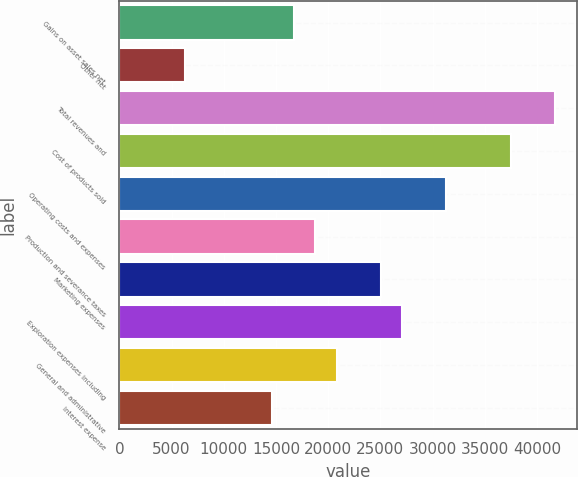<chart> <loc_0><loc_0><loc_500><loc_500><bar_chart><fcel>Gains on asset sales net<fcel>Other net<fcel>Total revenues and<fcel>Cost of products sold<fcel>Operating costs and expenses<fcel>Production and severance taxes<fcel>Marketing expenses<fcel>Exploration expenses including<fcel>General and administrative<fcel>Interest expense<nl><fcel>16684.9<fcel>6257.11<fcel>41711.6<fcel>37540.5<fcel>31283.8<fcel>18770.5<fcel>25027.2<fcel>27112.7<fcel>20856<fcel>14599.4<nl></chart> 